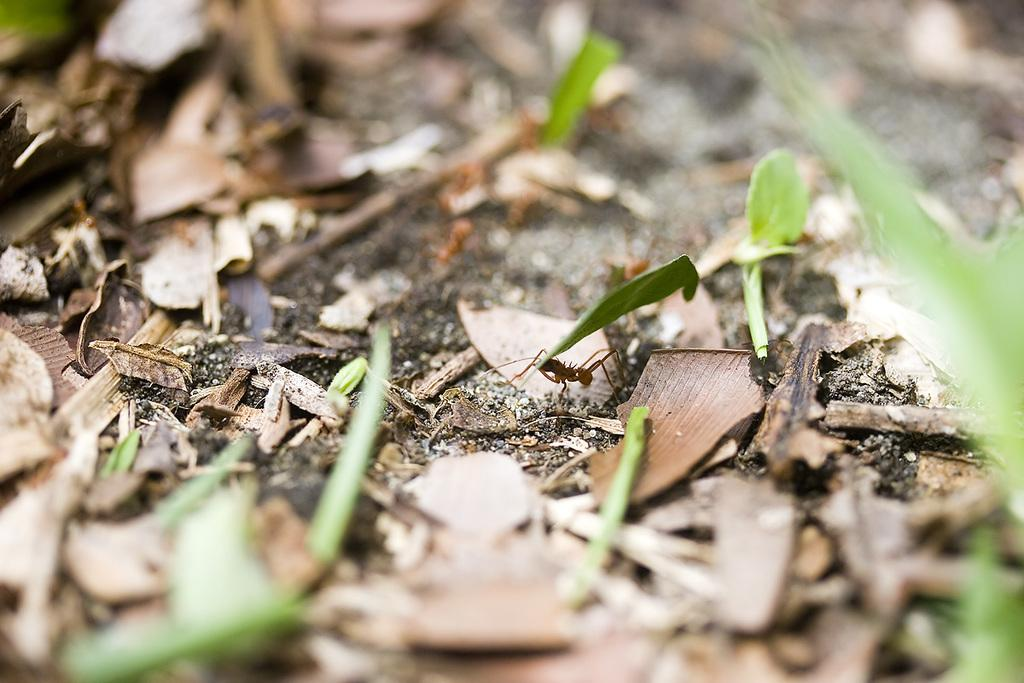What type of leaves can be seen on the ground in the image? There are dry leaves and green leaves on the ground in the image. Can you describe any living organisms present in the image? Yes, there is an ant on the ground in the image. What type of trail can be seen in the image? There is no trail visible in the image; it features dry and green leaves on the ground and an ant. How many quarters are present in the image? There are no quarters present in the image. 